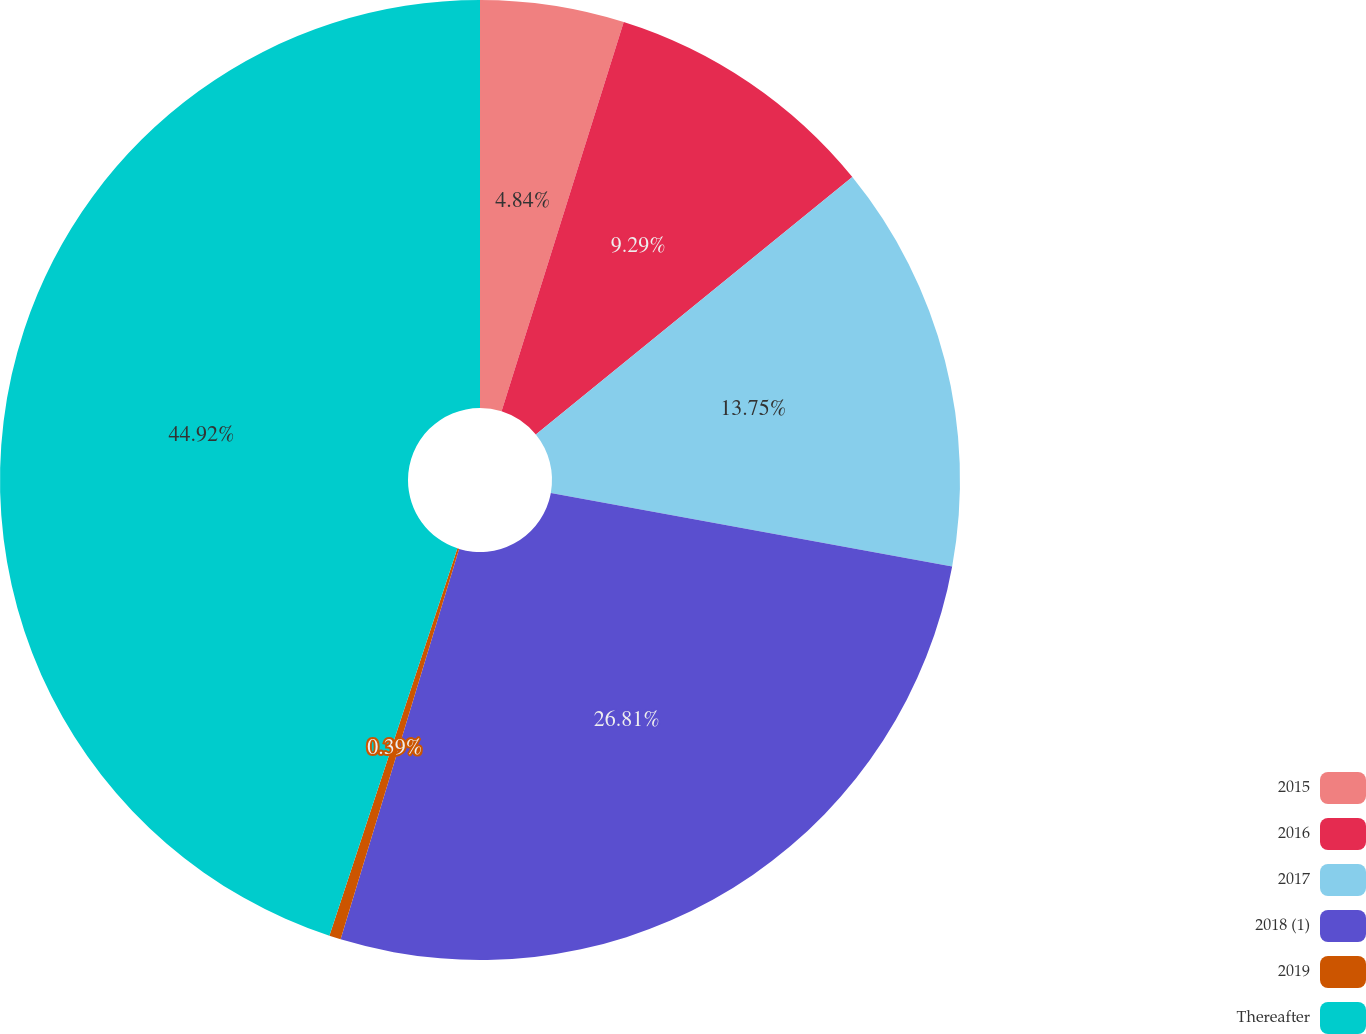<chart> <loc_0><loc_0><loc_500><loc_500><pie_chart><fcel>2015<fcel>2016<fcel>2017<fcel>2018 (1)<fcel>2019<fcel>Thereafter<nl><fcel>4.84%<fcel>9.29%<fcel>13.75%<fcel>26.81%<fcel>0.39%<fcel>44.92%<nl></chart> 